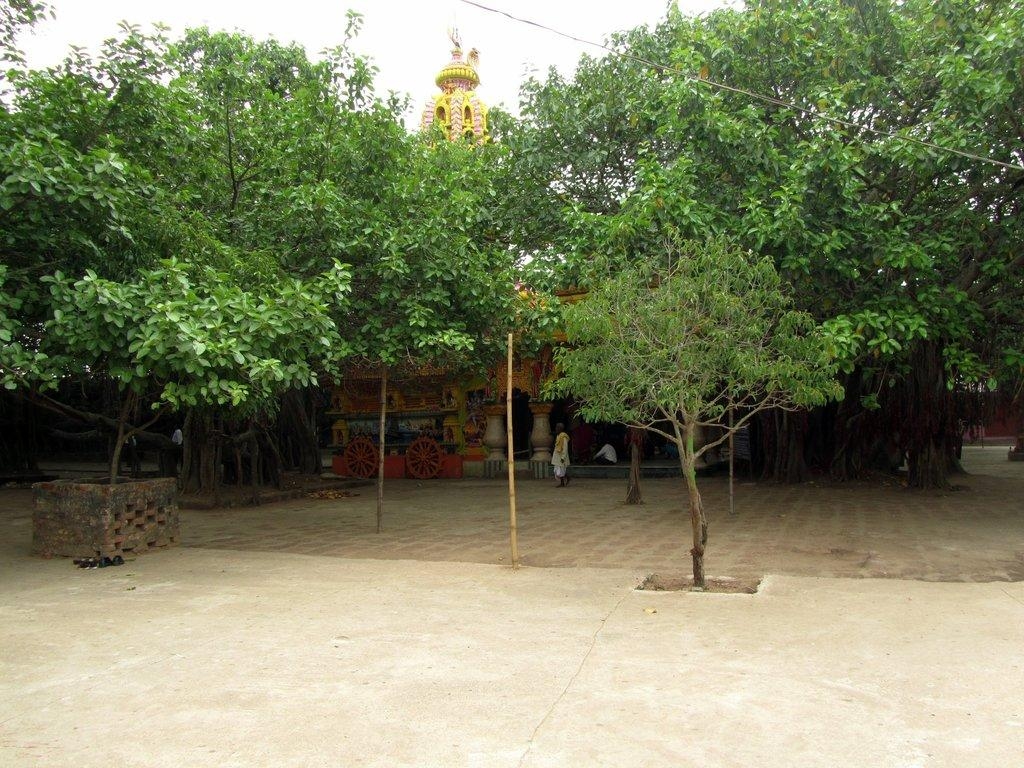What can be seen in the foreground of the image? There is empty land in the foreground of the image. What is visible in the background of the image? There are trees, people, a building structure, and the sky visible in the background of the image. Can you describe the vegetation in the image? There are trees in the background of the image. What type of structure can be seen in the background of the image? There appears to be a building structure in the background of the image. What is the dirt's belief about the people in the image? There is no dirt present in the image, and therefore it cannot have any beliefs. 